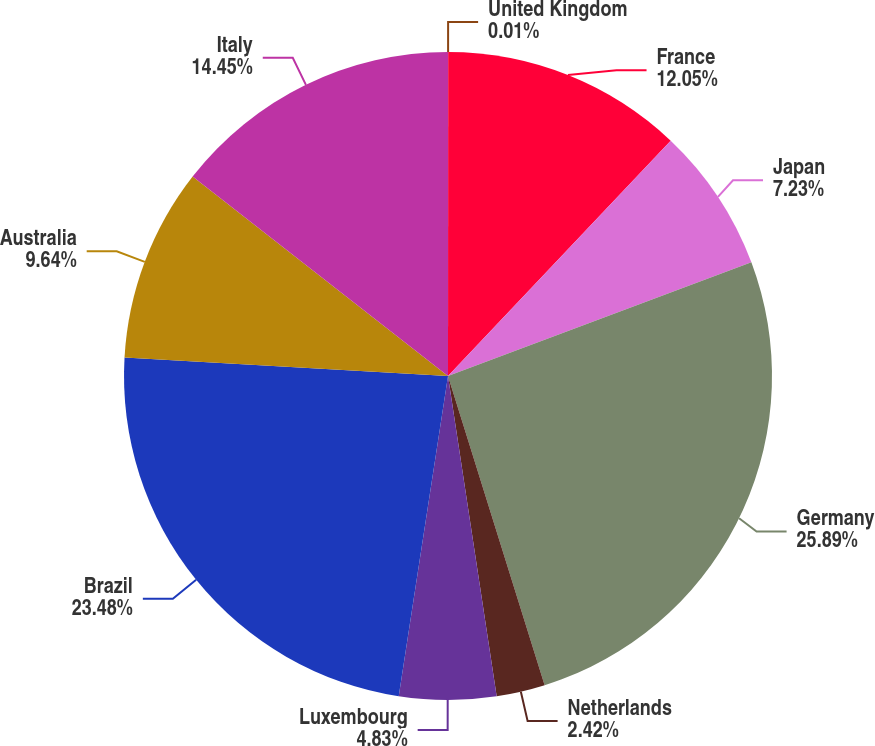<chart> <loc_0><loc_0><loc_500><loc_500><pie_chart><fcel>United Kingdom<fcel>France<fcel>Japan<fcel>Germany<fcel>Netherlands<fcel>Luxembourg<fcel>Brazil<fcel>Australia<fcel>Italy<nl><fcel>0.01%<fcel>12.05%<fcel>7.23%<fcel>25.89%<fcel>2.42%<fcel>4.83%<fcel>23.48%<fcel>9.64%<fcel>14.45%<nl></chart> 